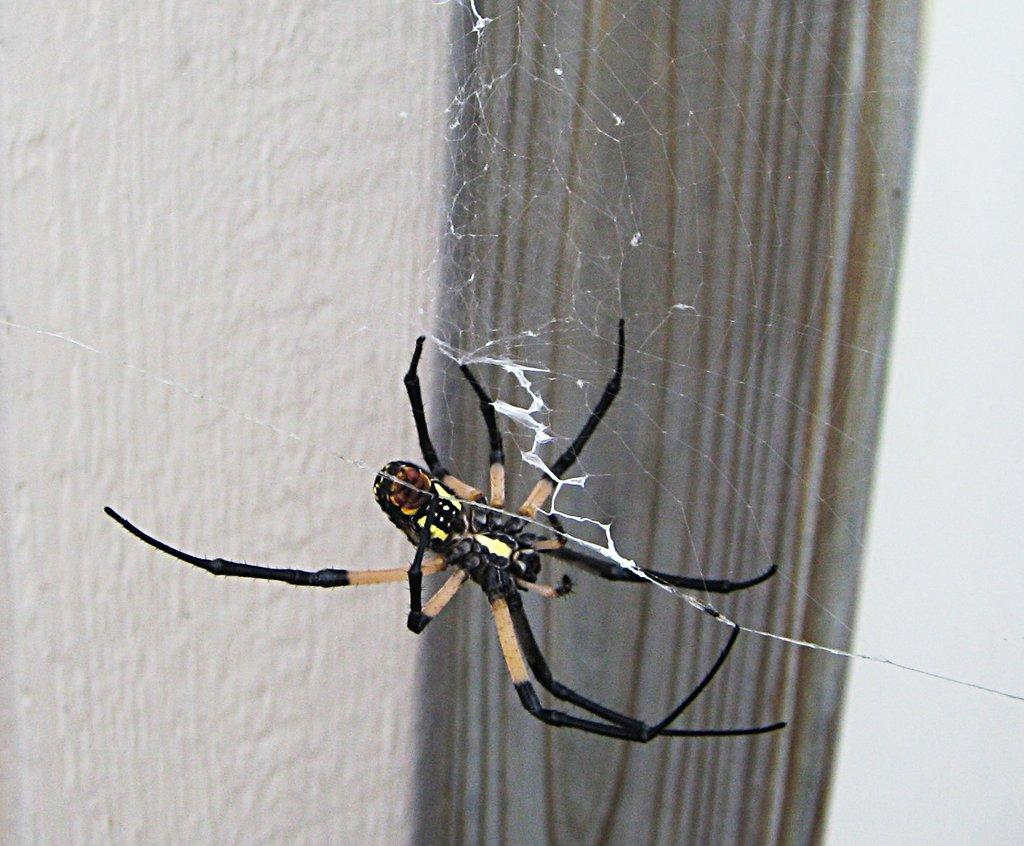What is located in the center of the image? There is a spider in the web in the center of the image. What can be seen in the background of the image? There is a wall in the background of the image. What type of plantation can be seen in the image? There is no plantation present in the image; it features a spider in a web and a wall in the background. How many bears are visible in the image? There are no bears present in the image. 